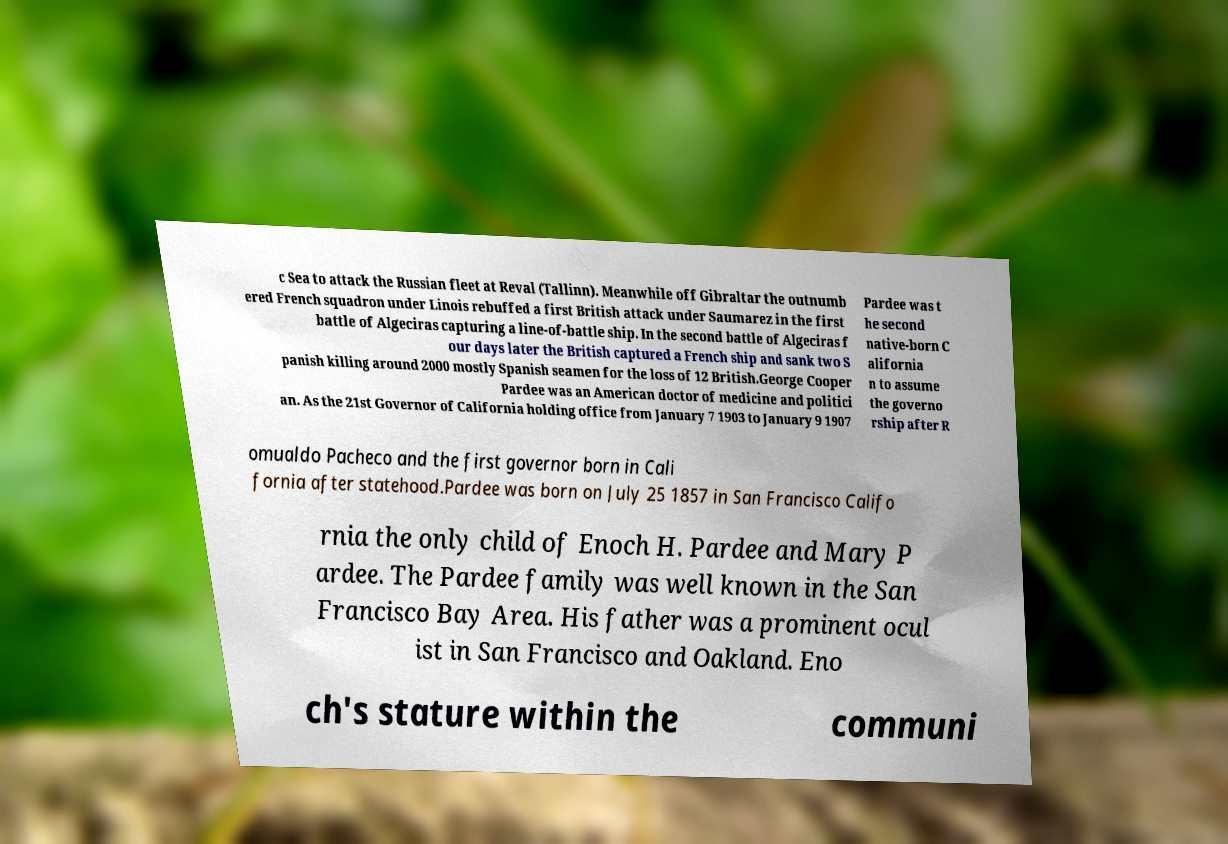What messages or text are displayed in this image? I need them in a readable, typed format. c Sea to attack the Russian fleet at Reval (Tallinn). Meanwhile off Gibraltar the outnumb ered French squadron under Linois rebuffed a first British attack under Saumarez in the first battle of Algeciras capturing a line-of-battle ship. In the second battle of Algeciras f our days later the British captured a French ship and sank two S panish killing around 2000 mostly Spanish seamen for the loss of 12 British.George Cooper Pardee was an American doctor of medicine and politici an. As the 21st Governor of California holding office from January 7 1903 to January 9 1907 Pardee was t he second native-born C alifornia n to assume the governo rship after R omualdo Pacheco and the first governor born in Cali fornia after statehood.Pardee was born on July 25 1857 in San Francisco Califo rnia the only child of Enoch H. Pardee and Mary P ardee. The Pardee family was well known in the San Francisco Bay Area. His father was a prominent ocul ist in San Francisco and Oakland. Eno ch's stature within the communi 